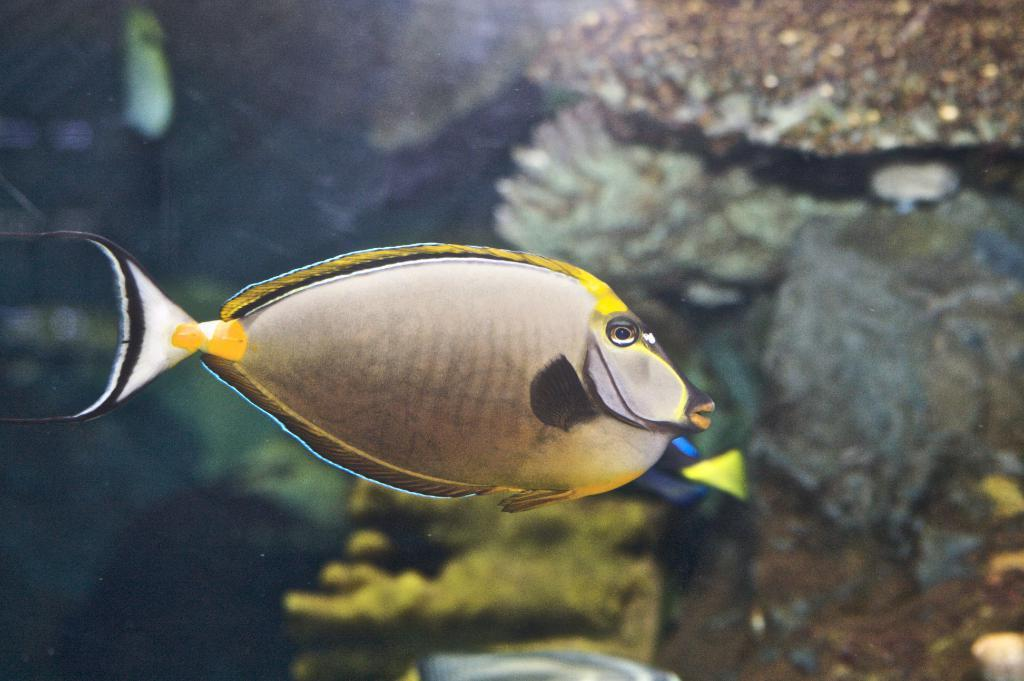What type of animal is in the image? There is a fish in the image. What colors can be seen on the fish? The color of the fish is yellow, black, and white. Can you describe the overall quality of the image? The image is slightly blurry in the background. What type of ground can be seen beneath the fish in the image? There is no ground visible in the image, as it appears to be underwater. What shape is the fish swimming in the image? The image does not show the fish swimming in a specific shape, such as a circle. 